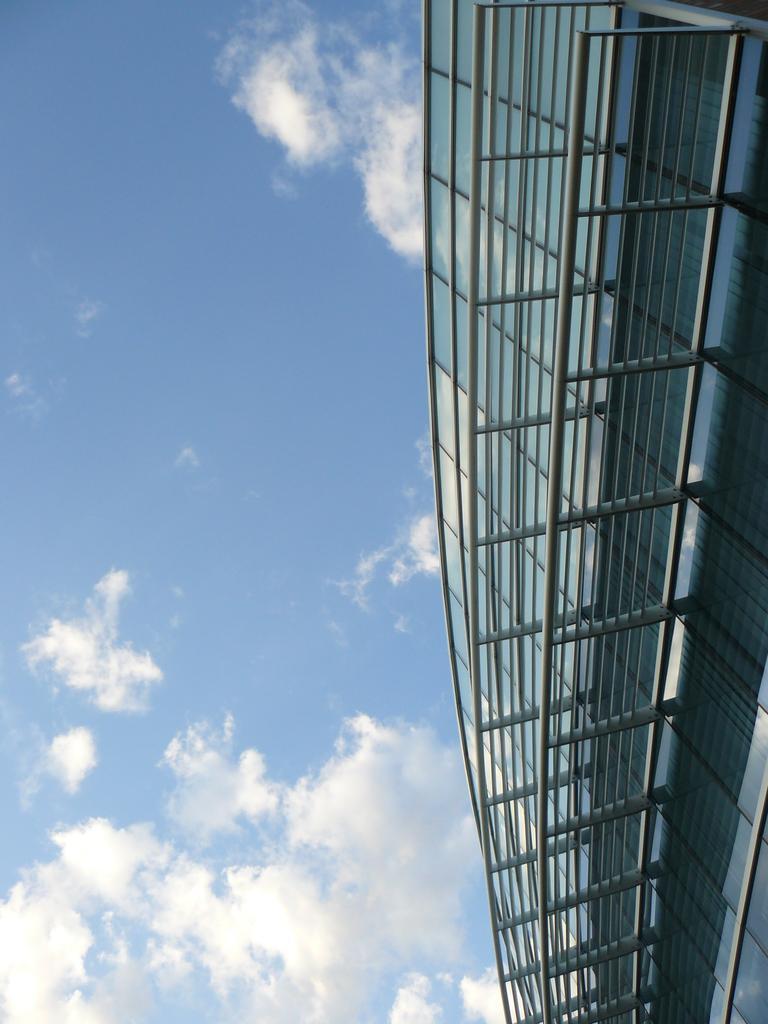Please provide a concise description of this image. Left side there is a building having fence. Left side there is sky with some clouds. 